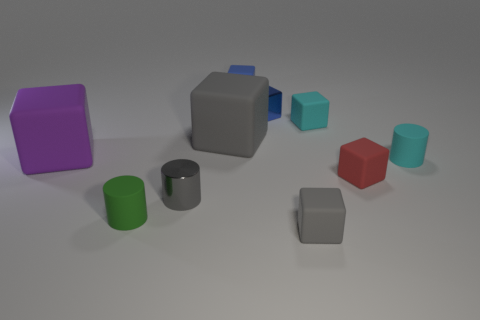Is the number of tiny objects on the right side of the gray shiny object greater than the number of gray metallic cylinders behind the red block?
Your answer should be compact. Yes. Is there another big gray object of the same shape as the large gray object?
Provide a succinct answer. No. Does the cyan matte thing in front of the cyan cube have the same size as the metallic block?
Provide a succinct answer. Yes. Are there any big purple things?
Offer a very short reply. Yes. What number of things are either blocks left of the small gray matte thing or tiny cyan objects?
Your response must be concise. 6. Does the metal block have the same color as the rubber cylinder that is to the left of the small blue matte cube?
Give a very brief answer. No. Are there any red cylinders of the same size as the red block?
Make the answer very short. No. The cylinder that is on the right side of the big rubber thing right of the small green matte thing is made of what material?
Keep it short and to the point. Rubber. What number of small cubes are the same color as the shiny cylinder?
Provide a short and direct response. 1. What is the shape of the big gray thing that is made of the same material as the large purple object?
Your response must be concise. Cube. 